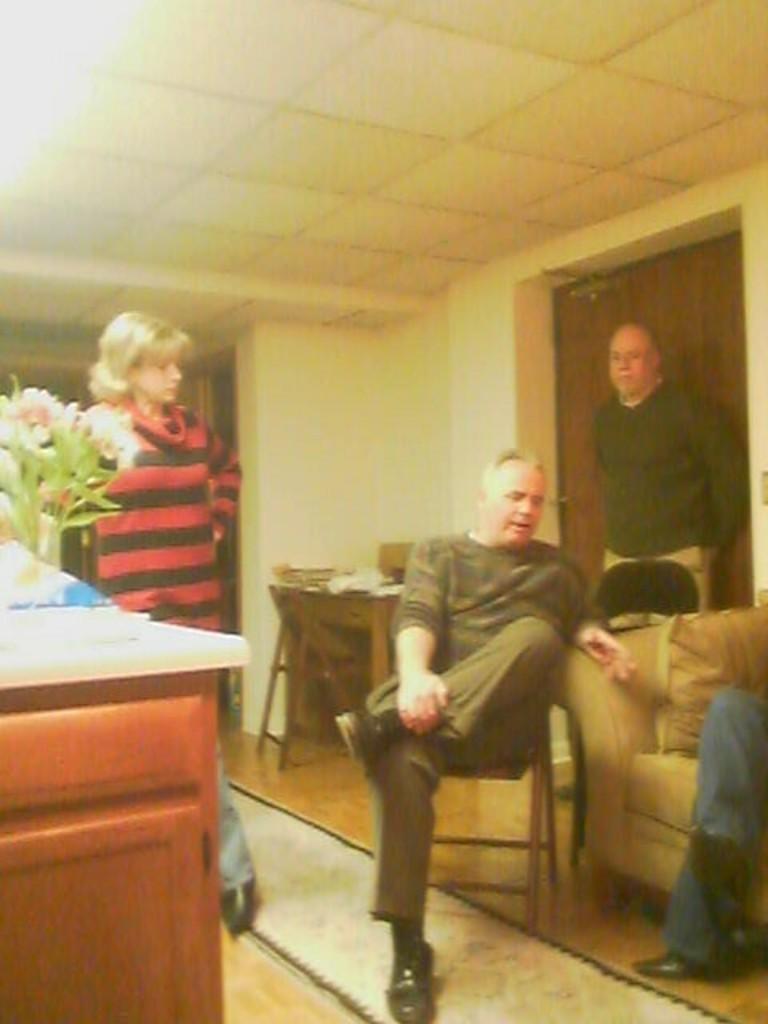In one or two sentences, can you explain what this image depicts? In this picture we can see two men and one woman where man is sitting on chair and talking and beside to him we have a sofa with pillows on it and at back of them table, chair and on table we have vase with flower and in background we can see wall. 